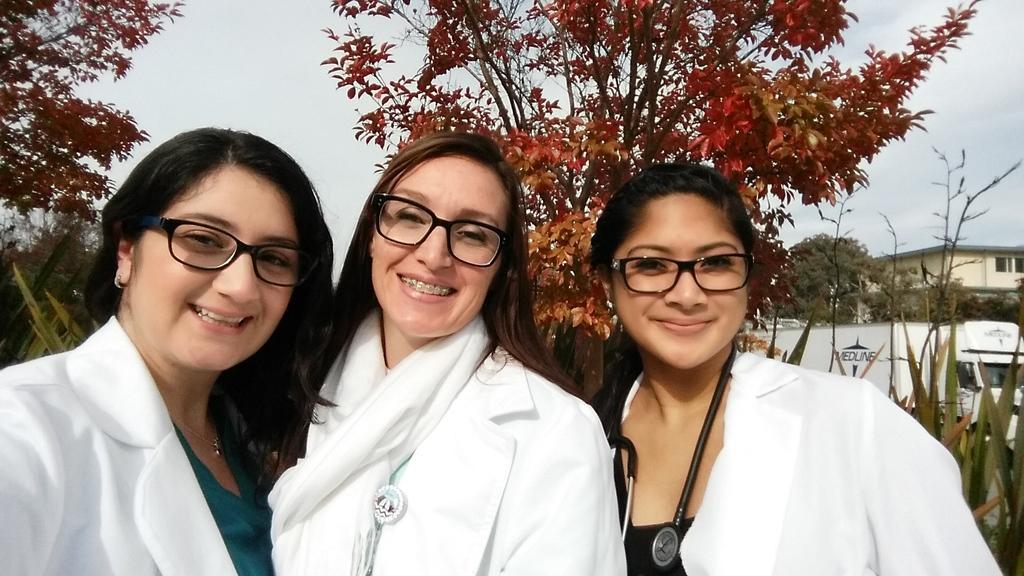Can you describe this image briefly? In this image we can see these three women wearing white coats and spectacles are smiling. In the background, we can see a vehicle, trees, house and the sky. 